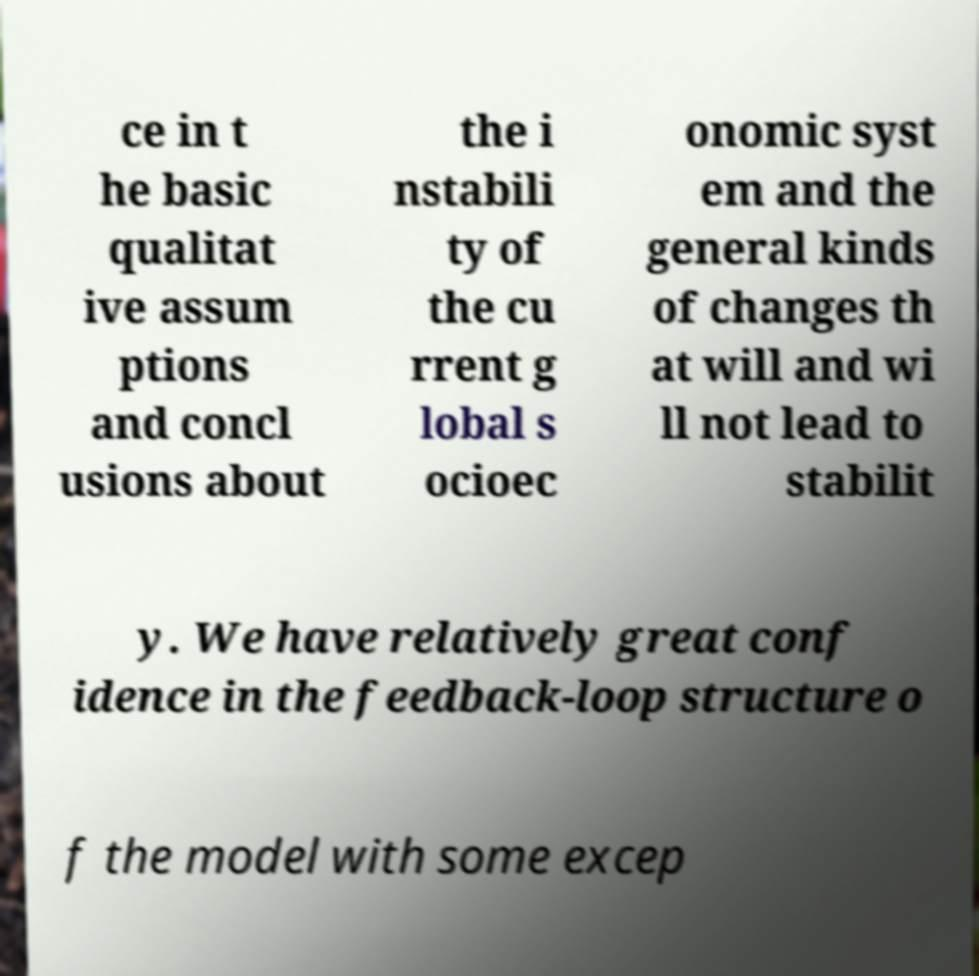Please identify and transcribe the text found in this image. ce in t he basic qualitat ive assum ptions and concl usions about the i nstabili ty of the cu rrent g lobal s ocioec onomic syst em and the general kinds of changes th at will and wi ll not lead to stabilit y. We have relatively great conf idence in the feedback-loop structure o f the model with some excep 